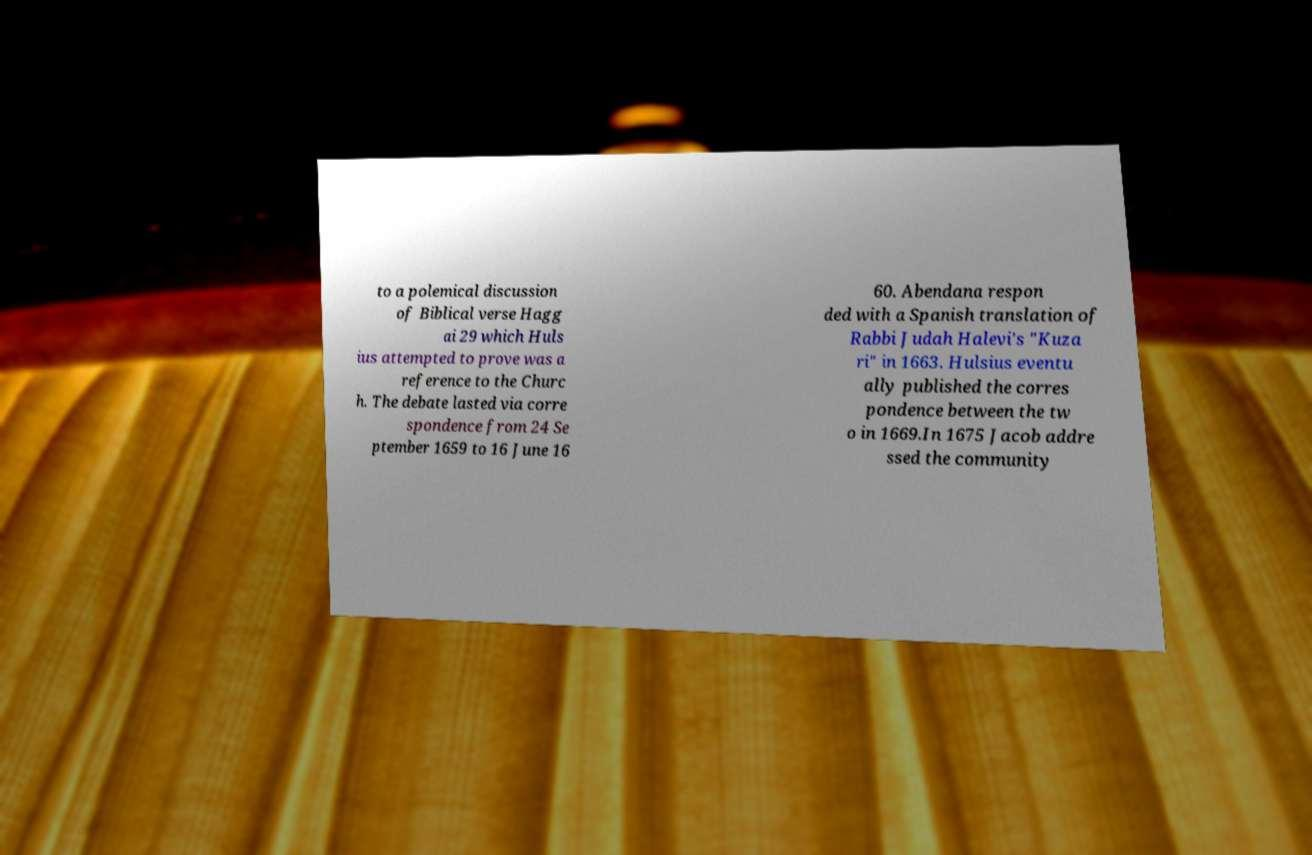I need the written content from this picture converted into text. Can you do that? to a polemical discussion of Biblical verse Hagg ai 29 which Huls ius attempted to prove was a reference to the Churc h. The debate lasted via corre spondence from 24 Se ptember 1659 to 16 June 16 60. Abendana respon ded with a Spanish translation of Rabbi Judah Halevi's "Kuza ri" in 1663. Hulsius eventu ally published the corres pondence between the tw o in 1669.In 1675 Jacob addre ssed the community 